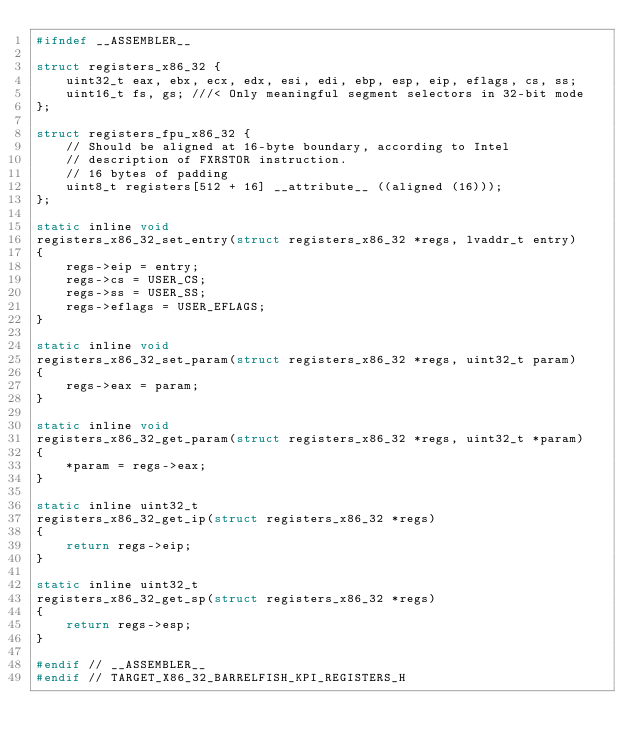<code> <loc_0><loc_0><loc_500><loc_500><_C_>#ifndef __ASSEMBLER__

struct registers_x86_32 {
    uint32_t eax, ebx, ecx, edx, esi, edi, ebp, esp, eip, eflags, cs, ss;
    uint16_t fs, gs; ///< Only meaningful segment selectors in 32-bit mode
};

struct registers_fpu_x86_32 {
    // Should be aligned at 16-byte boundary, according to Intel
    // description of FXRSTOR instruction.
    // 16 bytes of padding
    uint8_t registers[512 + 16] __attribute__ ((aligned (16)));
};

static inline void
registers_x86_32_set_entry(struct registers_x86_32 *regs, lvaddr_t entry)
{
    regs->eip = entry;
    regs->cs = USER_CS;
    regs->ss = USER_SS;
    regs->eflags = USER_EFLAGS;
}

static inline void
registers_x86_32_set_param(struct registers_x86_32 *regs, uint32_t param)
{
    regs->eax = param;
}

static inline void
registers_x86_32_get_param(struct registers_x86_32 *regs, uint32_t *param)
{
    *param = regs->eax;
}

static inline uint32_t
registers_x86_32_get_ip(struct registers_x86_32 *regs)
{
    return regs->eip;
}

static inline uint32_t
registers_x86_32_get_sp(struct registers_x86_32 *regs)
{
    return regs->esp;
}

#endif // __ASSEMBLER__
#endif // TARGET_X86_32_BARRELFISH_KPI_REGISTERS_H
</code> 